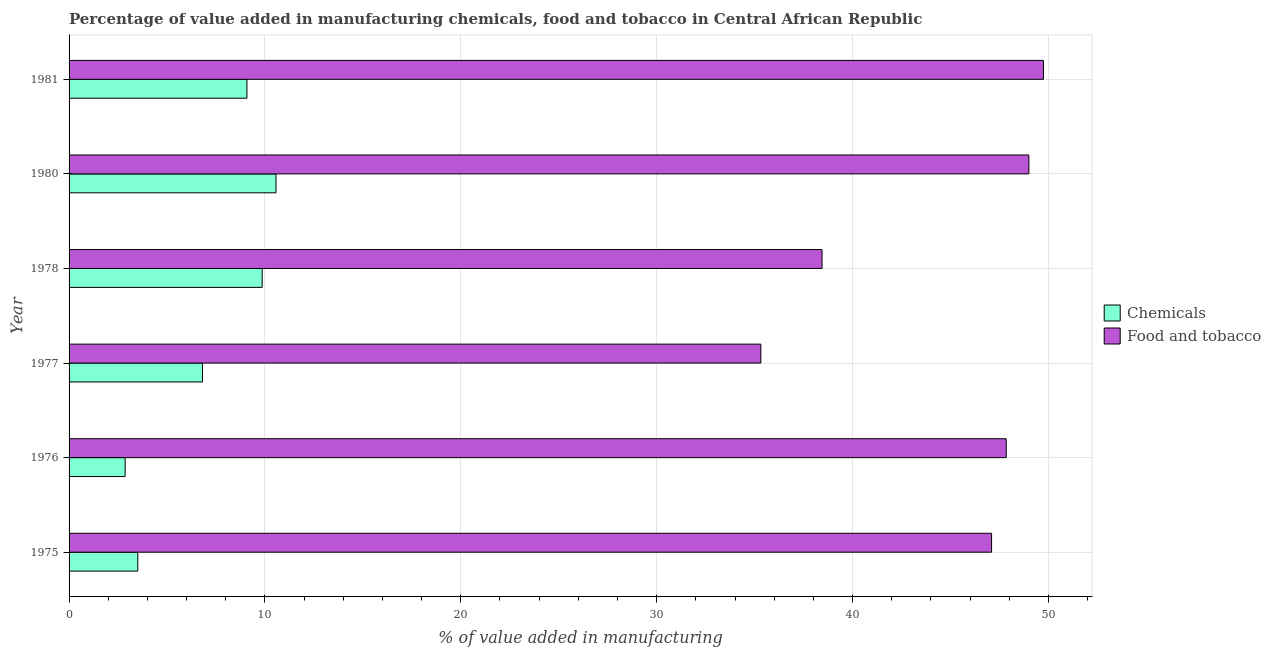Are the number of bars on each tick of the Y-axis equal?
Give a very brief answer. Yes. How many bars are there on the 2nd tick from the top?
Ensure brevity in your answer.  2. How many bars are there on the 1st tick from the bottom?
Offer a very short reply. 2. What is the label of the 5th group of bars from the top?
Offer a terse response. 1976. What is the value added by  manufacturing chemicals in 1980?
Your response must be concise. 10.57. Across all years, what is the maximum value added by  manufacturing chemicals?
Give a very brief answer. 10.57. Across all years, what is the minimum value added by manufacturing food and tobacco?
Provide a succinct answer. 35.32. In which year was the value added by manufacturing food and tobacco maximum?
Provide a short and direct response. 1981. In which year was the value added by  manufacturing chemicals minimum?
Keep it short and to the point. 1976. What is the total value added by  manufacturing chemicals in the graph?
Give a very brief answer. 42.69. What is the difference between the value added by manufacturing food and tobacco in 1978 and that in 1980?
Make the answer very short. -10.56. What is the difference between the value added by manufacturing food and tobacco in 1975 and the value added by  manufacturing chemicals in 1977?
Ensure brevity in your answer.  40.29. What is the average value added by manufacturing food and tobacco per year?
Keep it short and to the point. 44.58. In the year 1975, what is the difference between the value added by  manufacturing chemicals and value added by manufacturing food and tobacco?
Your answer should be very brief. -43.59. What is the ratio of the value added by manufacturing food and tobacco in 1975 to that in 1978?
Offer a very short reply. 1.23. Is the value added by manufacturing food and tobacco in 1977 less than that in 1980?
Your response must be concise. Yes. Is the difference between the value added by manufacturing food and tobacco in 1975 and 1981 greater than the difference between the value added by  manufacturing chemicals in 1975 and 1981?
Your answer should be very brief. Yes. What is the difference between the highest and the second highest value added by  manufacturing chemicals?
Your answer should be compact. 0.71. What is the difference between the highest and the lowest value added by  manufacturing chemicals?
Offer a very short reply. 7.7. In how many years, is the value added by  manufacturing chemicals greater than the average value added by  manufacturing chemicals taken over all years?
Your answer should be very brief. 3. What does the 1st bar from the top in 1981 represents?
Provide a short and direct response. Food and tobacco. What does the 1st bar from the bottom in 1981 represents?
Offer a terse response. Chemicals. How many bars are there?
Your response must be concise. 12. Are all the bars in the graph horizontal?
Offer a very short reply. Yes. How many years are there in the graph?
Make the answer very short. 6. What is the difference between two consecutive major ticks on the X-axis?
Provide a short and direct response. 10. Does the graph contain grids?
Make the answer very short. Yes. How many legend labels are there?
Offer a terse response. 2. How are the legend labels stacked?
Keep it short and to the point. Vertical. What is the title of the graph?
Your response must be concise. Percentage of value added in manufacturing chemicals, food and tobacco in Central African Republic. Does "Goods and services" appear as one of the legend labels in the graph?
Make the answer very short. No. What is the label or title of the X-axis?
Give a very brief answer. % of value added in manufacturing. What is the % of value added in manufacturing in Chemicals in 1975?
Offer a terse response. 3.51. What is the % of value added in manufacturing of Food and tobacco in 1975?
Offer a terse response. 47.1. What is the % of value added in manufacturing of Chemicals in 1976?
Keep it short and to the point. 2.86. What is the % of value added in manufacturing of Food and tobacco in 1976?
Your answer should be very brief. 47.85. What is the % of value added in manufacturing in Chemicals in 1977?
Offer a very short reply. 6.81. What is the % of value added in manufacturing in Food and tobacco in 1977?
Provide a short and direct response. 35.32. What is the % of value added in manufacturing in Chemicals in 1978?
Ensure brevity in your answer.  9.86. What is the % of value added in manufacturing in Food and tobacco in 1978?
Offer a very short reply. 38.44. What is the % of value added in manufacturing of Chemicals in 1980?
Your answer should be compact. 10.57. What is the % of value added in manufacturing of Food and tobacco in 1980?
Give a very brief answer. 49. What is the % of value added in manufacturing of Chemicals in 1981?
Offer a very short reply. 9.08. What is the % of value added in manufacturing in Food and tobacco in 1981?
Give a very brief answer. 49.75. Across all years, what is the maximum % of value added in manufacturing in Chemicals?
Offer a very short reply. 10.57. Across all years, what is the maximum % of value added in manufacturing in Food and tobacco?
Offer a very short reply. 49.75. Across all years, what is the minimum % of value added in manufacturing of Chemicals?
Keep it short and to the point. 2.86. Across all years, what is the minimum % of value added in manufacturing of Food and tobacco?
Your response must be concise. 35.32. What is the total % of value added in manufacturing of Chemicals in the graph?
Your answer should be compact. 42.69. What is the total % of value added in manufacturing in Food and tobacco in the graph?
Give a very brief answer. 267.46. What is the difference between the % of value added in manufacturing in Chemicals in 1975 and that in 1976?
Keep it short and to the point. 0.65. What is the difference between the % of value added in manufacturing of Food and tobacco in 1975 and that in 1976?
Provide a short and direct response. -0.75. What is the difference between the % of value added in manufacturing of Chemicals in 1975 and that in 1977?
Provide a short and direct response. -3.3. What is the difference between the % of value added in manufacturing in Food and tobacco in 1975 and that in 1977?
Your answer should be very brief. 11.78. What is the difference between the % of value added in manufacturing in Chemicals in 1975 and that in 1978?
Your answer should be very brief. -6.35. What is the difference between the % of value added in manufacturing in Food and tobacco in 1975 and that in 1978?
Ensure brevity in your answer.  8.66. What is the difference between the % of value added in manufacturing of Chemicals in 1975 and that in 1980?
Your response must be concise. -7.06. What is the difference between the % of value added in manufacturing in Food and tobacco in 1975 and that in 1980?
Your answer should be very brief. -1.91. What is the difference between the % of value added in manufacturing in Chemicals in 1975 and that in 1981?
Ensure brevity in your answer.  -5.57. What is the difference between the % of value added in manufacturing of Food and tobacco in 1975 and that in 1981?
Keep it short and to the point. -2.65. What is the difference between the % of value added in manufacturing of Chemicals in 1976 and that in 1977?
Provide a short and direct response. -3.95. What is the difference between the % of value added in manufacturing in Food and tobacco in 1976 and that in 1977?
Your response must be concise. 12.53. What is the difference between the % of value added in manufacturing in Chemicals in 1976 and that in 1978?
Provide a succinct answer. -7. What is the difference between the % of value added in manufacturing of Food and tobacco in 1976 and that in 1978?
Ensure brevity in your answer.  9.41. What is the difference between the % of value added in manufacturing of Chemicals in 1976 and that in 1980?
Your answer should be very brief. -7.7. What is the difference between the % of value added in manufacturing in Food and tobacco in 1976 and that in 1980?
Offer a very short reply. -1.16. What is the difference between the % of value added in manufacturing in Chemicals in 1976 and that in 1981?
Give a very brief answer. -6.22. What is the difference between the % of value added in manufacturing in Food and tobacco in 1976 and that in 1981?
Keep it short and to the point. -1.9. What is the difference between the % of value added in manufacturing in Chemicals in 1977 and that in 1978?
Your response must be concise. -3.05. What is the difference between the % of value added in manufacturing of Food and tobacco in 1977 and that in 1978?
Your response must be concise. -3.12. What is the difference between the % of value added in manufacturing of Chemicals in 1977 and that in 1980?
Offer a terse response. -3.75. What is the difference between the % of value added in manufacturing in Food and tobacco in 1977 and that in 1980?
Provide a succinct answer. -13.68. What is the difference between the % of value added in manufacturing of Chemicals in 1977 and that in 1981?
Your answer should be compact. -2.27. What is the difference between the % of value added in manufacturing in Food and tobacco in 1977 and that in 1981?
Give a very brief answer. -14.43. What is the difference between the % of value added in manufacturing of Chemicals in 1978 and that in 1980?
Your answer should be very brief. -0.71. What is the difference between the % of value added in manufacturing of Food and tobacco in 1978 and that in 1980?
Ensure brevity in your answer.  -10.56. What is the difference between the % of value added in manufacturing of Chemicals in 1978 and that in 1981?
Offer a terse response. 0.78. What is the difference between the % of value added in manufacturing of Food and tobacco in 1978 and that in 1981?
Your response must be concise. -11.31. What is the difference between the % of value added in manufacturing of Chemicals in 1980 and that in 1981?
Your response must be concise. 1.49. What is the difference between the % of value added in manufacturing of Food and tobacco in 1980 and that in 1981?
Ensure brevity in your answer.  -0.74. What is the difference between the % of value added in manufacturing in Chemicals in 1975 and the % of value added in manufacturing in Food and tobacco in 1976?
Keep it short and to the point. -44.34. What is the difference between the % of value added in manufacturing in Chemicals in 1975 and the % of value added in manufacturing in Food and tobacco in 1977?
Your response must be concise. -31.81. What is the difference between the % of value added in manufacturing of Chemicals in 1975 and the % of value added in manufacturing of Food and tobacco in 1978?
Your response must be concise. -34.93. What is the difference between the % of value added in manufacturing in Chemicals in 1975 and the % of value added in manufacturing in Food and tobacco in 1980?
Give a very brief answer. -45.5. What is the difference between the % of value added in manufacturing in Chemicals in 1975 and the % of value added in manufacturing in Food and tobacco in 1981?
Offer a very short reply. -46.24. What is the difference between the % of value added in manufacturing in Chemicals in 1976 and the % of value added in manufacturing in Food and tobacco in 1977?
Give a very brief answer. -32.46. What is the difference between the % of value added in manufacturing of Chemicals in 1976 and the % of value added in manufacturing of Food and tobacco in 1978?
Give a very brief answer. -35.58. What is the difference between the % of value added in manufacturing in Chemicals in 1976 and the % of value added in manufacturing in Food and tobacco in 1980?
Give a very brief answer. -46.14. What is the difference between the % of value added in manufacturing in Chemicals in 1976 and the % of value added in manufacturing in Food and tobacco in 1981?
Your response must be concise. -46.89. What is the difference between the % of value added in manufacturing in Chemicals in 1977 and the % of value added in manufacturing in Food and tobacco in 1978?
Your response must be concise. -31.63. What is the difference between the % of value added in manufacturing in Chemicals in 1977 and the % of value added in manufacturing in Food and tobacco in 1980?
Your response must be concise. -42.19. What is the difference between the % of value added in manufacturing in Chemicals in 1977 and the % of value added in manufacturing in Food and tobacco in 1981?
Offer a very short reply. -42.94. What is the difference between the % of value added in manufacturing of Chemicals in 1978 and the % of value added in manufacturing of Food and tobacco in 1980?
Offer a very short reply. -39.15. What is the difference between the % of value added in manufacturing in Chemicals in 1978 and the % of value added in manufacturing in Food and tobacco in 1981?
Give a very brief answer. -39.89. What is the difference between the % of value added in manufacturing in Chemicals in 1980 and the % of value added in manufacturing in Food and tobacco in 1981?
Your response must be concise. -39.18. What is the average % of value added in manufacturing of Chemicals per year?
Offer a terse response. 7.11. What is the average % of value added in manufacturing in Food and tobacco per year?
Your answer should be very brief. 44.58. In the year 1975, what is the difference between the % of value added in manufacturing of Chemicals and % of value added in manufacturing of Food and tobacco?
Provide a succinct answer. -43.59. In the year 1976, what is the difference between the % of value added in manufacturing in Chemicals and % of value added in manufacturing in Food and tobacco?
Your answer should be very brief. -44.98. In the year 1977, what is the difference between the % of value added in manufacturing in Chemicals and % of value added in manufacturing in Food and tobacco?
Keep it short and to the point. -28.51. In the year 1978, what is the difference between the % of value added in manufacturing in Chemicals and % of value added in manufacturing in Food and tobacco?
Make the answer very short. -28.58. In the year 1980, what is the difference between the % of value added in manufacturing in Chemicals and % of value added in manufacturing in Food and tobacco?
Give a very brief answer. -38.44. In the year 1981, what is the difference between the % of value added in manufacturing in Chemicals and % of value added in manufacturing in Food and tobacco?
Give a very brief answer. -40.67. What is the ratio of the % of value added in manufacturing of Chemicals in 1975 to that in 1976?
Your answer should be compact. 1.23. What is the ratio of the % of value added in manufacturing in Food and tobacco in 1975 to that in 1976?
Ensure brevity in your answer.  0.98. What is the ratio of the % of value added in manufacturing in Chemicals in 1975 to that in 1977?
Make the answer very short. 0.52. What is the ratio of the % of value added in manufacturing in Food and tobacco in 1975 to that in 1977?
Give a very brief answer. 1.33. What is the ratio of the % of value added in manufacturing of Chemicals in 1975 to that in 1978?
Your response must be concise. 0.36. What is the ratio of the % of value added in manufacturing in Food and tobacco in 1975 to that in 1978?
Provide a succinct answer. 1.23. What is the ratio of the % of value added in manufacturing in Chemicals in 1975 to that in 1980?
Give a very brief answer. 0.33. What is the ratio of the % of value added in manufacturing in Food and tobacco in 1975 to that in 1980?
Your answer should be compact. 0.96. What is the ratio of the % of value added in manufacturing in Chemicals in 1975 to that in 1981?
Keep it short and to the point. 0.39. What is the ratio of the % of value added in manufacturing of Food and tobacco in 1975 to that in 1981?
Your response must be concise. 0.95. What is the ratio of the % of value added in manufacturing of Chemicals in 1976 to that in 1977?
Ensure brevity in your answer.  0.42. What is the ratio of the % of value added in manufacturing of Food and tobacco in 1976 to that in 1977?
Provide a succinct answer. 1.35. What is the ratio of the % of value added in manufacturing in Chemicals in 1976 to that in 1978?
Provide a short and direct response. 0.29. What is the ratio of the % of value added in manufacturing in Food and tobacco in 1976 to that in 1978?
Provide a short and direct response. 1.24. What is the ratio of the % of value added in manufacturing of Chemicals in 1976 to that in 1980?
Your answer should be compact. 0.27. What is the ratio of the % of value added in manufacturing of Food and tobacco in 1976 to that in 1980?
Your response must be concise. 0.98. What is the ratio of the % of value added in manufacturing in Chemicals in 1976 to that in 1981?
Offer a terse response. 0.32. What is the ratio of the % of value added in manufacturing in Food and tobacco in 1976 to that in 1981?
Your answer should be compact. 0.96. What is the ratio of the % of value added in manufacturing of Chemicals in 1977 to that in 1978?
Give a very brief answer. 0.69. What is the ratio of the % of value added in manufacturing of Food and tobacco in 1977 to that in 1978?
Your answer should be very brief. 0.92. What is the ratio of the % of value added in manufacturing in Chemicals in 1977 to that in 1980?
Offer a very short reply. 0.64. What is the ratio of the % of value added in manufacturing in Food and tobacco in 1977 to that in 1980?
Make the answer very short. 0.72. What is the ratio of the % of value added in manufacturing of Chemicals in 1977 to that in 1981?
Make the answer very short. 0.75. What is the ratio of the % of value added in manufacturing of Food and tobacco in 1977 to that in 1981?
Offer a very short reply. 0.71. What is the ratio of the % of value added in manufacturing of Chemicals in 1978 to that in 1980?
Your answer should be very brief. 0.93. What is the ratio of the % of value added in manufacturing of Food and tobacco in 1978 to that in 1980?
Your answer should be compact. 0.78. What is the ratio of the % of value added in manufacturing of Chemicals in 1978 to that in 1981?
Offer a very short reply. 1.09. What is the ratio of the % of value added in manufacturing in Food and tobacco in 1978 to that in 1981?
Your answer should be compact. 0.77. What is the ratio of the % of value added in manufacturing of Chemicals in 1980 to that in 1981?
Offer a very short reply. 1.16. What is the difference between the highest and the second highest % of value added in manufacturing of Chemicals?
Provide a short and direct response. 0.71. What is the difference between the highest and the second highest % of value added in manufacturing of Food and tobacco?
Keep it short and to the point. 0.74. What is the difference between the highest and the lowest % of value added in manufacturing of Chemicals?
Offer a very short reply. 7.7. What is the difference between the highest and the lowest % of value added in manufacturing of Food and tobacco?
Your answer should be compact. 14.43. 